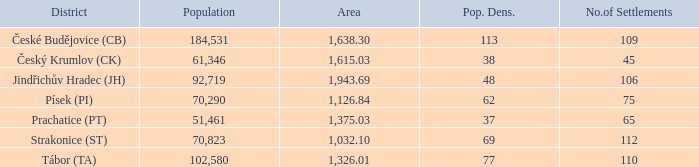What is the dimension of the zone having a population density of 113 and a population greater than 184,531? 0.0. Help me parse the entirety of this table. {'header': ['District', 'Population', 'Area', 'Pop. Dens.', 'No.of Settlements'], 'rows': [['České Budějovice (CB)', '184,531', '1,638.30', '113', '109'], ['Český Krumlov (CK)', '61,346', '1,615.03', '38', '45'], ['Jindřichův Hradec (JH)', '92,719', '1,943.69', '48', '106'], ['Písek (PI)', '70,290', '1,126.84', '62', '75'], ['Prachatice (PT)', '51,461', '1,375.03', '37', '65'], ['Strakonice (ST)', '70,823', '1,032.10', '69', '112'], ['Tábor (TA)', '102,580', '1,326.01', '77', '110']]} 